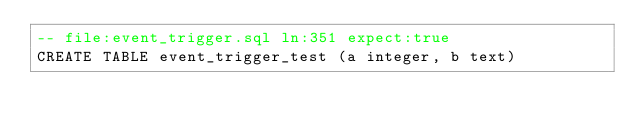<code> <loc_0><loc_0><loc_500><loc_500><_SQL_>-- file:event_trigger.sql ln:351 expect:true
CREATE TABLE event_trigger_test (a integer, b text)
</code> 